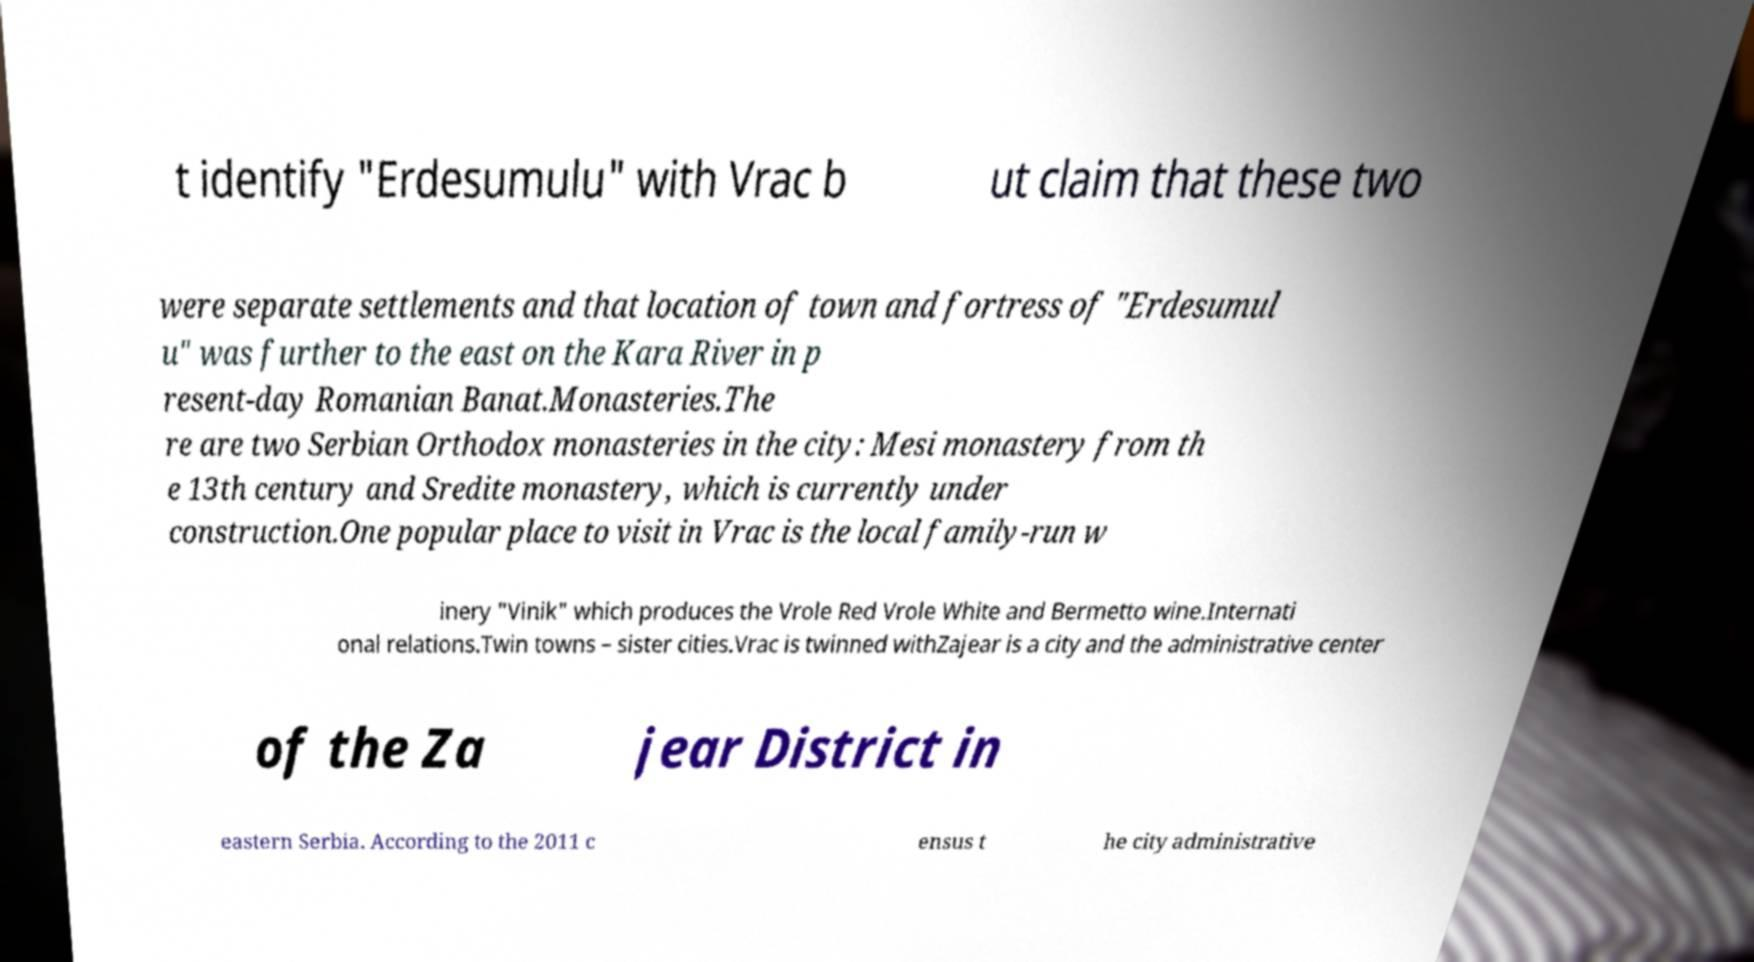There's text embedded in this image that I need extracted. Can you transcribe it verbatim? t identify "Erdesumulu" with Vrac b ut claim that these two were separate settlements and that location of town and fortress of "Erdesumul u" was further to the east on the Kara River in p resent-day Romanian Banat.Monasteries.The re are two Serbian Orthodox monasteries in the city: Mesi monastery from th e 13th century and Sredite monastery, which is currently under construction.One popular place to visit in Vrac is the local family-run w inery "Vinik" which produces the Vrole Red Vrole White and Bermetto wine.Internati onal relations.Twin towns – sister cities.Vrac is twinned withZajear is a city and the administrative center of the Za jear District in eastern Serbia. According to the 2011 c ensus t he city administrative 